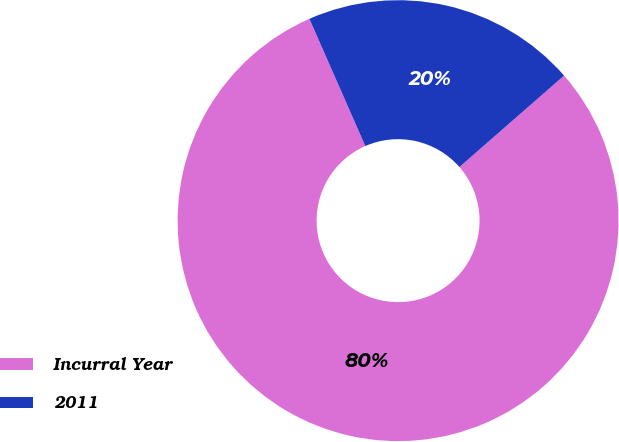Convert chart. <chart><loc_0><loc_0><loc_500><loc_500><pie_chart><fcel>Incurral Year<fcel>2011<nl><fcel>79.84%<fcel>20.16%<nl></chart> 